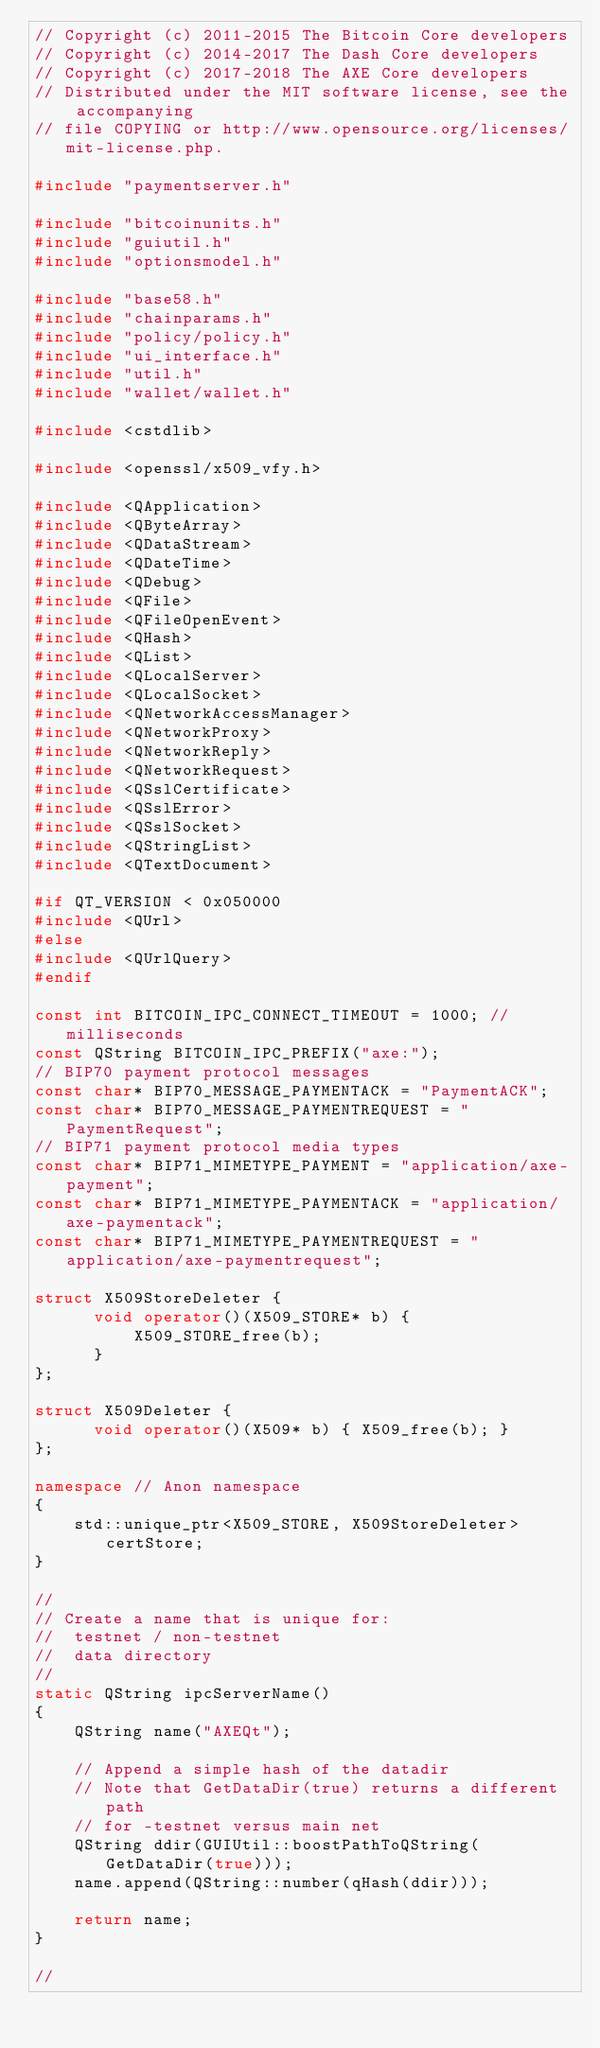Convert code to text. <code><loc_0><loc_0><loc_500><loc_500><_C++_>// Copyright (c) 2011-2015 The Bitcoin Core developers
// Copyright (c) 2014-2017 The Dash Core developers
// Copyright (c) 2017-2018 The AXE Core developers
// Distributed under the MIT software license, see the accompanying
// file COPYING or http://www.opensource.org/licenses/mit-license.php.

#include "paymentserver.h"

#include "bitcoinunits.h"
#include "guiutil.h"
#include "optionsmodel.h"

#include "base58.h"
#include "chainparams.h"
#include "policy/policy.h"
#include "ui_interface.h"
#include "util.h"
#include "wallet/wallet.h"

#include <cstdlib>

#include <openssl/x509_vfy.h>

#include <QApplication>
#include <QByteArray>
#include <QDataStream>
#include <QDateTime>
#include <QDebug>
#include <QFile>
#include <QFileOpenEvent>
#include <QHash>
#include <QList>
#include <QLocalServer>
#include <QLocalSocket>
#include <QNetworkAccessManager>
#include <QNetworkProxy>
#include <QNetworkReply>
#include <QNetworkRequest>
#include <QSslCertificate>
#include <QSslError>
#include <QSslSocket>
#include <QStringList>
#include <QTextDocument>

#if QT_VERSION < 0x050000
#include <QUrl>
#else
#include <QUrlQuery>
#endif

const int BITCOIN_IPC_CONNECT_TIMEOUT = 1000; // milliseconds
const QString BITCOIN_IPC_PREFIX("axe:");
// BIP70 payment protocol messages
const char* BIP70_MESSAGE_PAYMENTACK = "PaymentACK";
const char* BIP70_MESSAGE_PAYMENTREQUEST = "PaymentRequest";
// BIP71 payment protocol media types
const char* BIP71_MIMETYPE_PAYMENT = "application/axe-payment";
const char* BIP71_MIMETYPE_PAYMENTACK = "application/axe-paymentack";
const char* BIP71_MIMETYPE_PAYMENTREQUEST = "application/axe-paymentrequest";

struct X509StoreDeleter {
      void operator()(X509_STORE* b) {
          X509_STORE_free(b);
      }
};

struct X509Deleter {
      void operator()(X509* b) { X509_free(b); }
};

namespace // Anon namespace
{
    std::unique_ptr<X509_STORE, X509StoreDeleter> certStore;
}

//
// Create a name that is unique for:
//  testnet / non-testnet
//  data directory
//
static QString ipcServerName()
{
    QString name("AXEQt");

    // Append a simple hash of the datadir
    // Note that GetDataDir(true) returns a different path
    // for -testnet versus main net
    QString ddir(GUIUtil::boostPathToQString(GetDataDir(true)));
    name.append(QString::number(qHash(ddir)));

    return name;
}

//</code> 